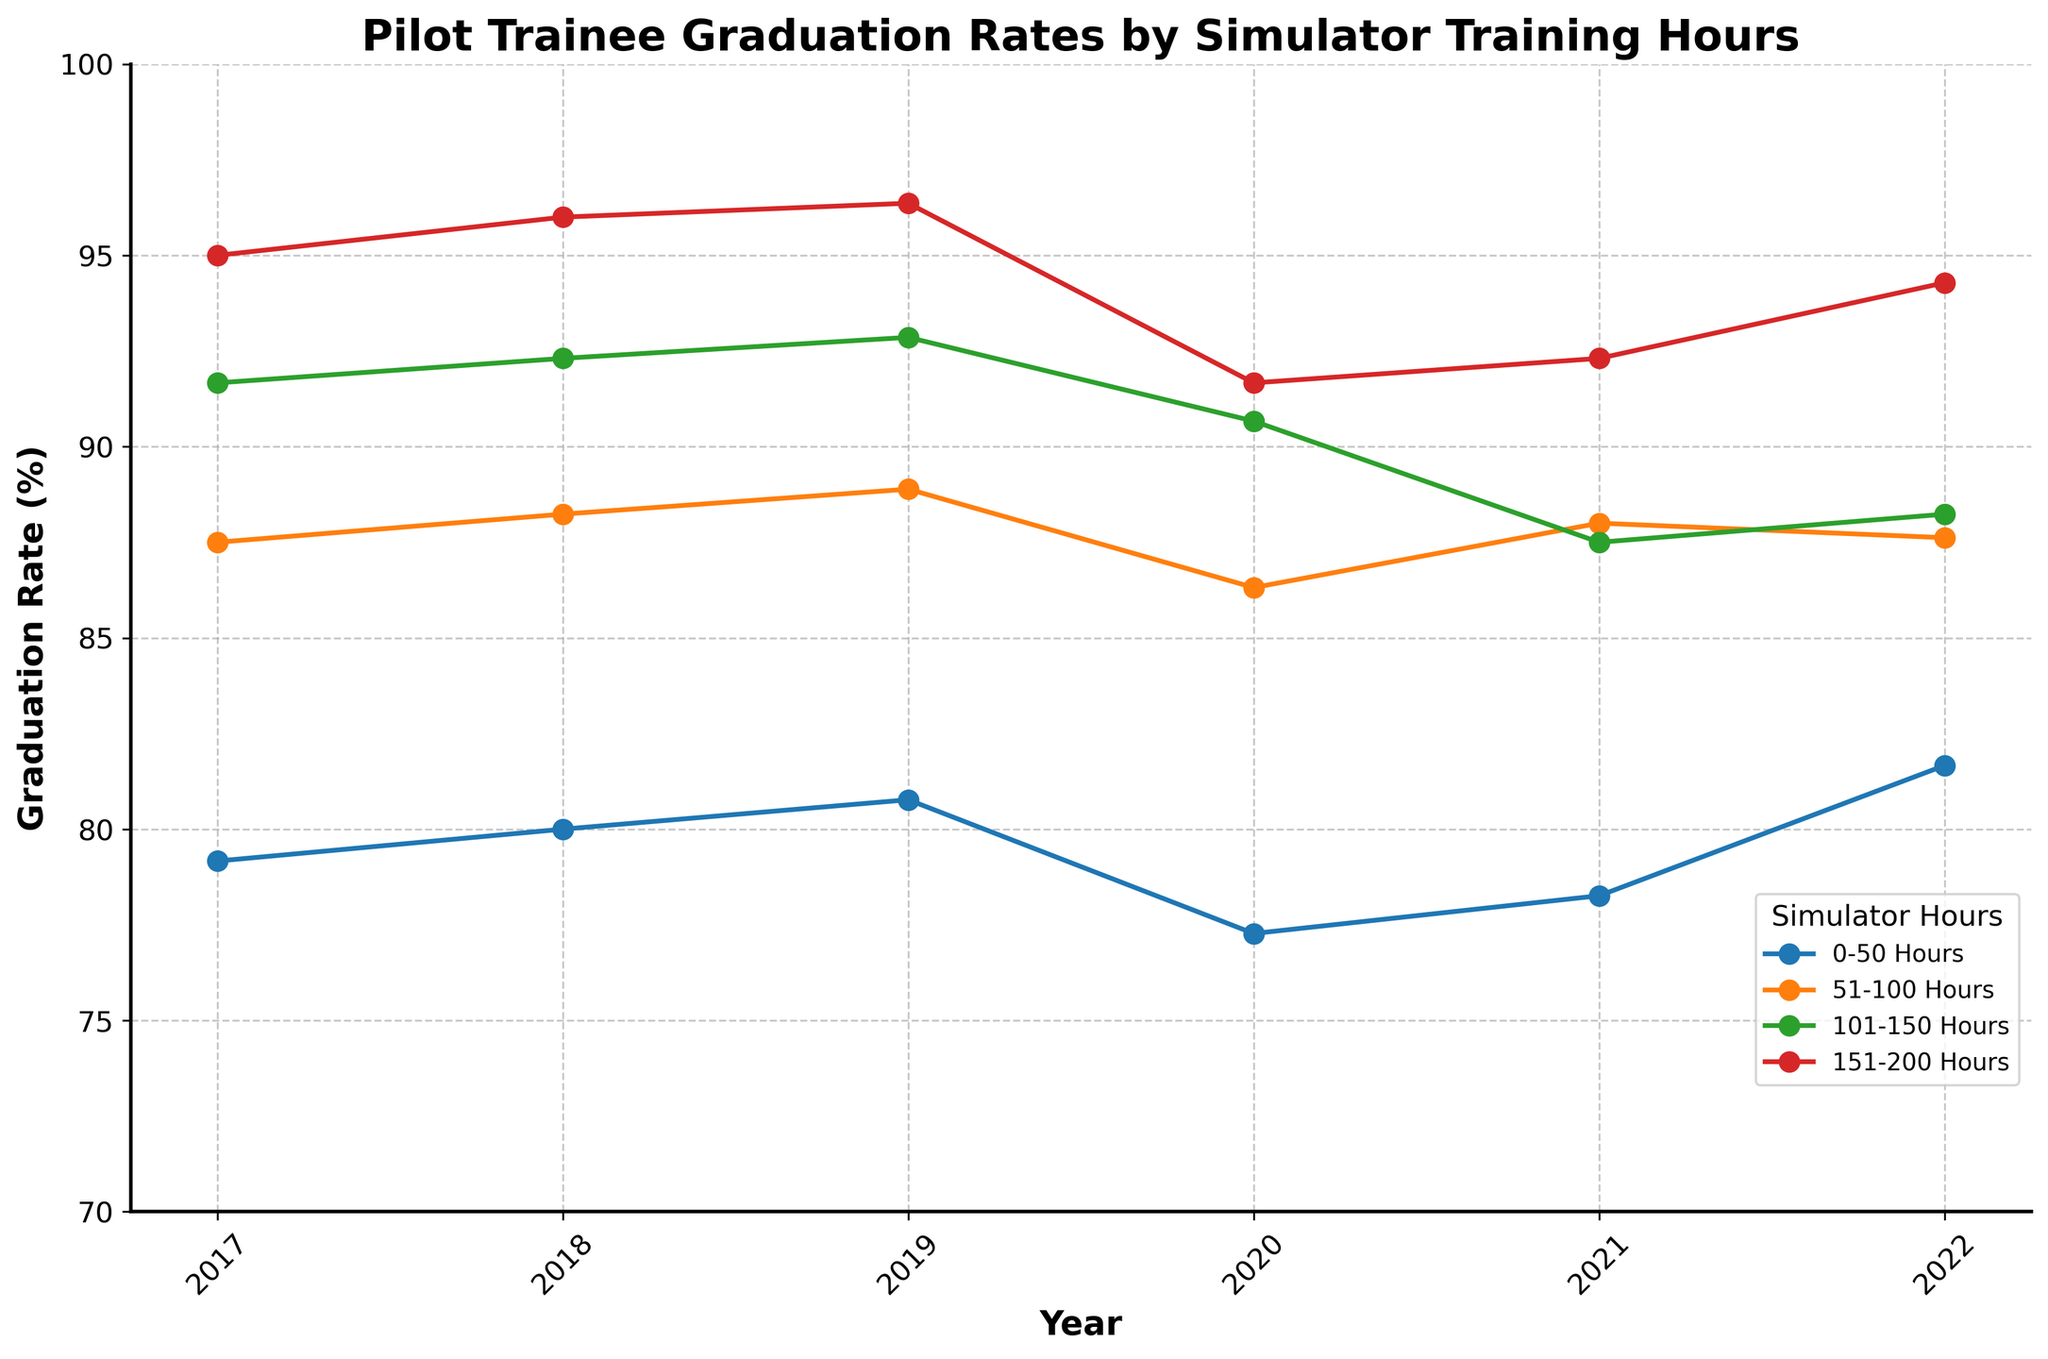What is the title of the plot? The title is usually displayed at the top of the figure. Here it shows 'Pilot Trainee Graduation Rates by Simulator Training Hours'.
Answer: Pilot Trainee Graduation Rates by Simulator Training Hours What are the categories of simulator hours shown in the legend? The legend is found on the figure, typically at one of the corners. It displays '0-50 Hours', '51-100 Hours', '101-150 Hours', '151-200 Hours'.
Answer: 0-50 Hours, 51-100 Hours, 101-150 Hours, 151-200 Hours In which year did the '0-50 Hours' category have the highest graduation rate? To find this, look at the line marked for '0-50 Hours' across different years. The highest graduation rate is visually at its peak in 2019.
Answer: 2019 Which simulator hours category showed the lowest graduation rate in 2020? Check the data points for 2020 across all categories and compare their positions. '0-50 Hours' is visibly the lowest.
Answer: 0-50 Hours Between 2021 and 2022, which simulator hours category had an increase in graduation rate? Examine the slope of lines between these two years. The line for '0-50 Hours' goes up, indicating an increase.
Answer: 0-50 Hours Is there a trend in the graduation rates for the '151-200 Hours' category from 2017 to 2022? Observe the line for '151-200 Hours' over the years. It shows a fairly consistent upward trend.
Answer: Yes, increasing In what year did all four simulator hours categories have their highest graduation rates? Compare the peaks in each category's line. 2022 stands out as the year when all lines are at their highest.
Answer: 2022 What is the approximate graduation rate for the '101-150 Hours' category in 2018? Follow the '101-150 Hours' line to where it intersects the 2018 vertical line. It is around 92%.
Answer: 92% Which year saw the smallest spread in graduation rates between the '0-50 Hours' and '151-200 Hours' categories? Look for the years where the vertical distances between these two lines are the smallest. In 2017, the difference appears minimal.
Answer: 2017 How does the graduation rate of the '51-100 Hours' category in 2018 compare to that in 2017? Check the '51-100 Hours' line for the points in 2017 and 2018. The rate in 2018 is higher.
Answer: Higher in 2018 